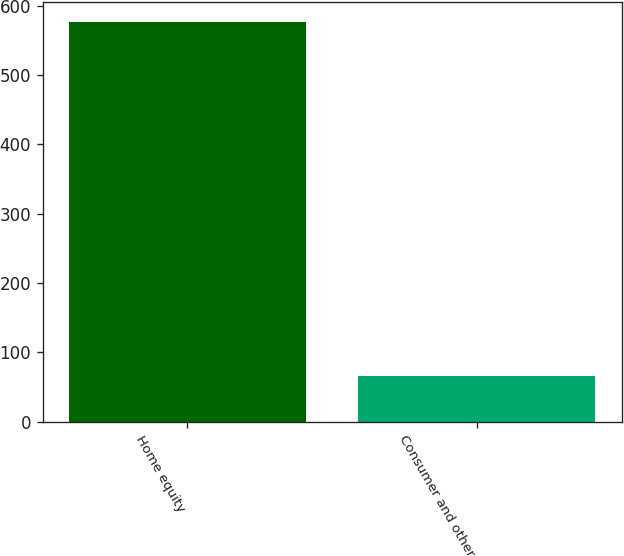<chart> <loc_0><loc_0><loc_500><loc_500><bar_chart><fcel>Home equity<fcel>Consumer and other<nl><fcel>576.1<fcel>65.5<nl></chart> 